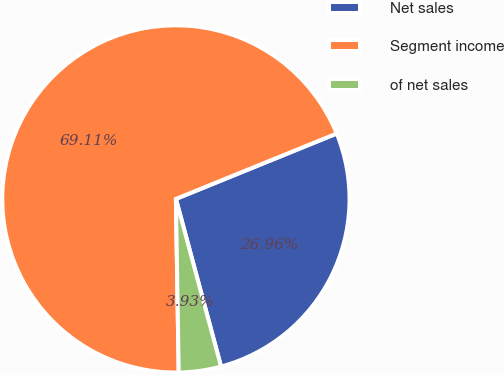Convert chart. <chart><loc_0><loc_0><loc_500><loc_500><pie_chart><fcel>Net sales<fcel>Segment income<fcel>of net sales<nl><fcel>26.96%<fcel>69.11%<fcel>3.93%<nl></chart> 